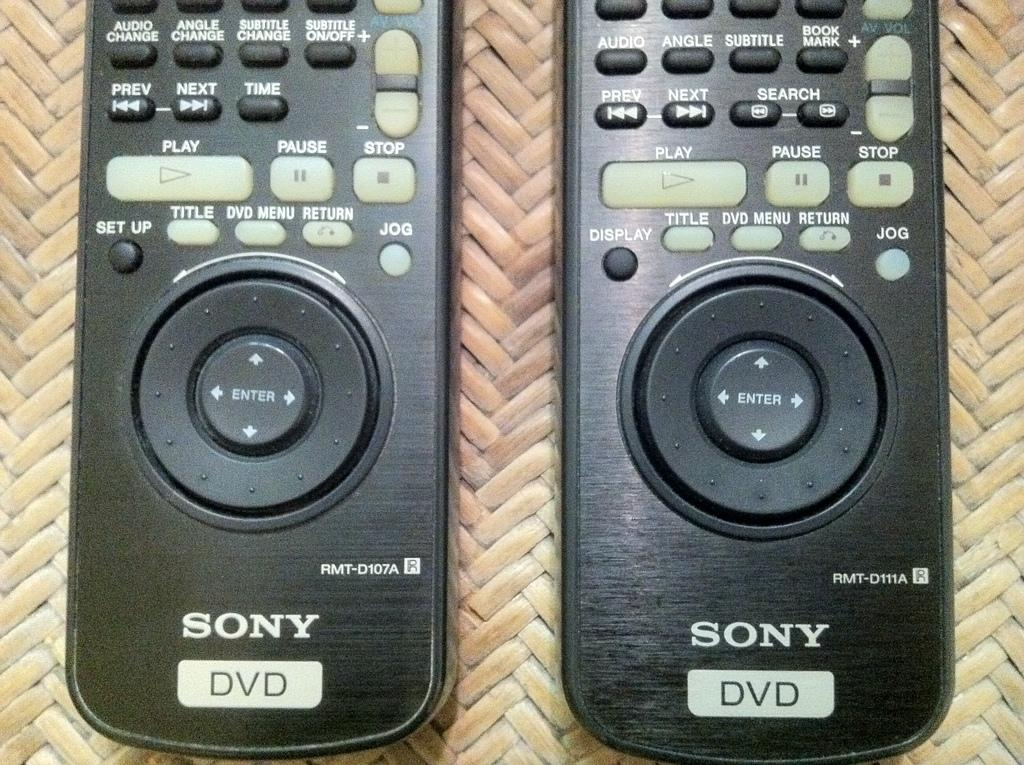<image>
Present a compact description of the photo's key features. Two Sony black DVD remotes next to one another. 